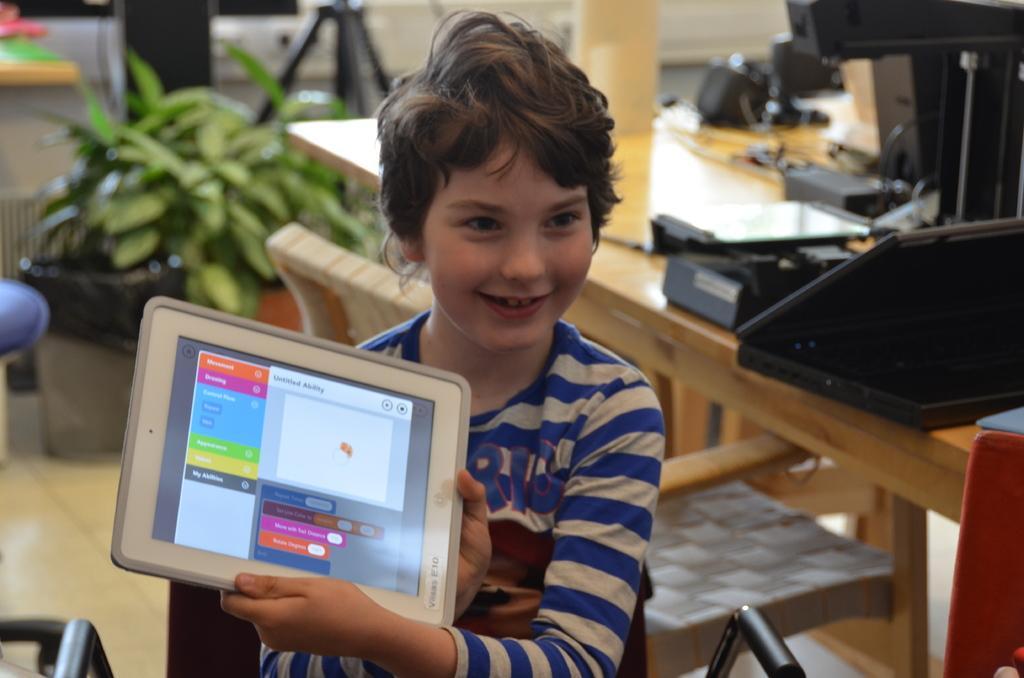How would you summarize this image in a sentence or two? In this image I see a child who is holding an electronic device and the child is smiling. In the background I see a table on which there is a laptop and other few things, I can also see a plant over here. 